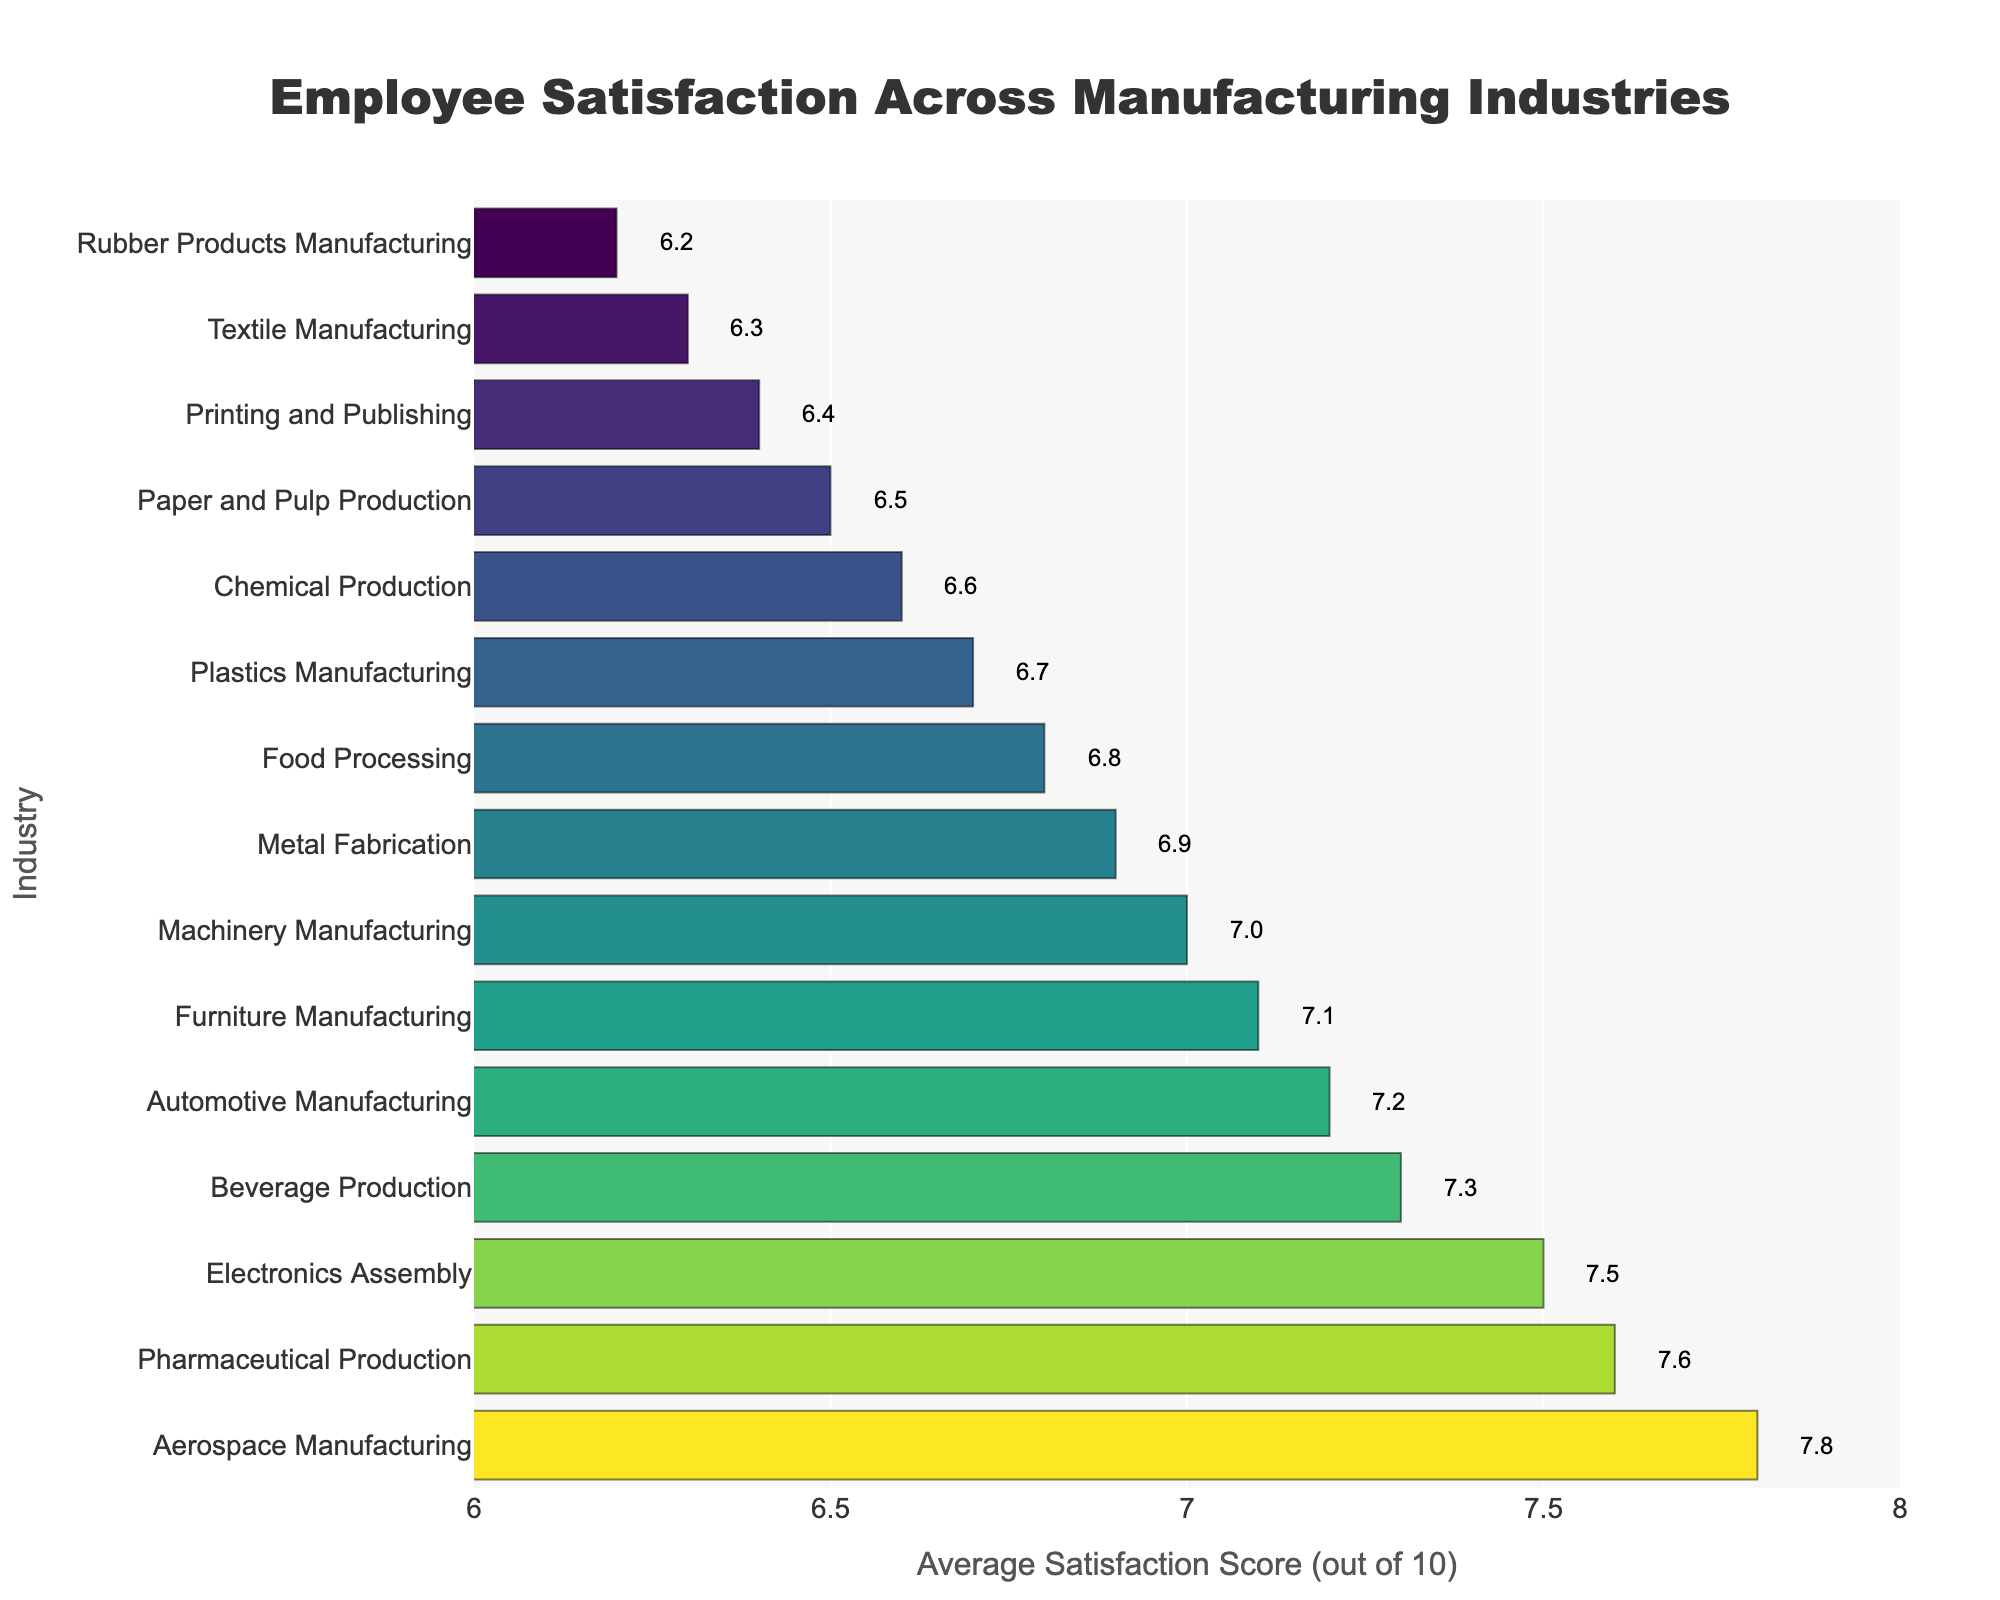Which industry has the highest employee satisfaction level? By observing the length of the bars, the Aerospace Manufacturing industry has the highest bar with a satisfaction score of 7.8.
Answer: Aerospace Manufacturing Which two industries have the closest employee satisfaction scores? Comparing the lengths of the bars shows that Metal Fabrication (6.9) and Food Processing (6.8) have the closest satisfaction scores.
Answer: Metal Fabrication and Food Processing What is the difference in employee satisfaction between Automotive Manufacturing and Pharmaceutical Production? The satisfaction score for Automotive Manufacturing is 7.2 and for Pharmaceutical Production is 7.6. The difference is therefore 7.6 - 7.2.
Answer: 0.4 What is the average employee satisfaction score for the lowest three industries? The lowest three industries are Rubber Products Manufacturing (6.2), Textile Manufacturing (6.3), and Printing and Publishing (6.4). Their average score is calculated as (6.2 + 6.3 + 6.4) / 3.
Answer: 6.3 Which industry has a higher employee satisfaction level: Beverage Production or Chemical Production? Beverage Production has a satisfaction score of 7.3, while Chemical Production has a score of 6.6. Therefore, Beverage Production has a higher score.
Answer: Beverage Production How many industries have an employee satisfaction score greater than 7? The industries with scores greater than 7 are Aerospace Manufacturing (7.8), Pharmaceutical Production (7.6), Electronics Assembly (7.5), Beverage Production (7.3), Automotive Manufacturing (7.2), and Furniture Manufacturing (7.1). Counting these industries gives a total of 6.
Answer: 6 What is the median employee satisfaction score across all industries? By ordering the scores from highest to lowest and finding the middle value: (7.8, 7.6, 7.5, 7.3, 7.2, 7.1, 7.0, 6.9, 6.8, 6.7, 6.6, 6.5, 6.4, 6.3, 6.2), the median value, being the 8th value in an ordered list of 15, is 6.9.
Answer: 6.9 What color represents the highest employee satisfaction level on the plot? By observing the color gradient on the plot, the highest satisfaction score (7.8) is represented by the darkest shade on the Viridis color scale, likely a deep blue or violet color.
Answer: Deep blue or violet Which industry has the lowest employee satisfaction level? By observing the length of the bars, the Rubber Products Manufacturing industry has the shortest bar with a satisfaction score of 6.2.
Answer: Rubber Products Manufacturing 